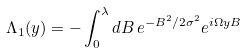<formula> <loc_0><loc_0><loc_500><loc_500>\Lambda _ { 1 } ( y ) = - \int _ { 0 } ^ { \lambda } d B \, e ^ { - B ^ { 2 } / 2 \sigma ^ { 2 } } e ^ { i \Omega y B }</formula> 